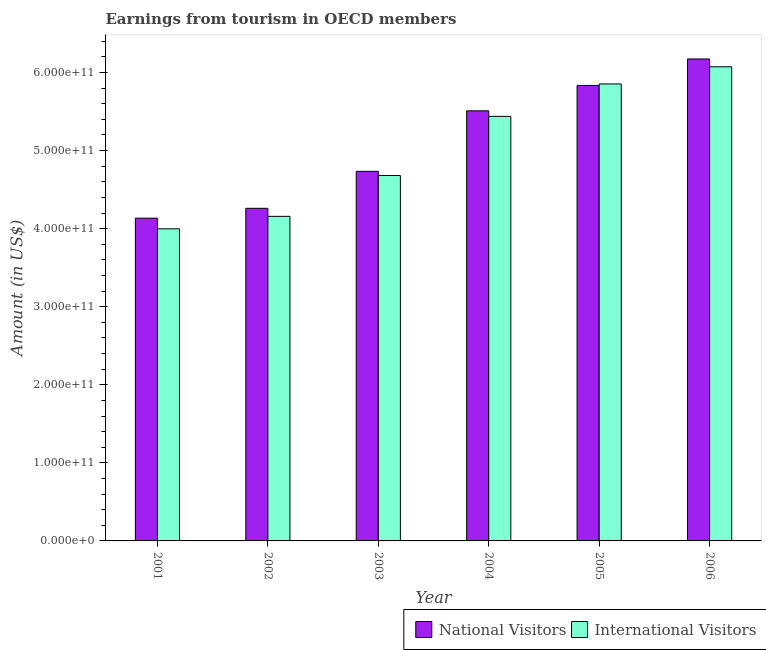How many different coloured bars are there?
Your answer should be very brief. 2. How many groups of bars are there?
Keep it short and to the point. 6. Are the number of bars on each tick of the X-axis equal?
Your response must be concise. Yes. How many bars are there on the 6th tick from the left?
Give a very brief answer. 2. How many bars are there on the 2nd tick from the right?
Ensure brevity in your answer.  2. What is the label of the 2nd group of bars from the left?
Provide a succinct answer. 2002. What is the amount earned from national visitors in 2004?
Offer a very short reply. 5.51e+11. Across all years, what is the maximum amount earned from national visitors?
Your answer should be very brief. 6.17e+11. Across all years, what is the minimum amount earned from national visitors?
Offer a terse response. 4.13e+11. What is the total amount earned from international visitors in the graph?
Offer a terse response. 3.02e+12. What is the difference between the amount earned from international visitors in 2002 and that in 2005?
Your answer should be compact. -1.70e+11. What is the difference between the amount earned from international visitors in 2001 and the amount earned from national visitors in 2004?
Make the answer very short. -1.44e+11. What is the average amount earned from international visitors per year?
Your answer should be very brief. 5.03e+11. In the year 2003, what is the difference between the amount earned from international visitors and amount earned from national visitors?
Ensure brevity in your answer.  0. What is the ratio of the amount earned from national visitors in 2003 to that in 2004?
Your answer should be compact. 0.86. Is the difference between the amount earned from international visitors in 2004 and 2006 greater than the difference between the amount earned from national visitors in 2004 and 2006?
Ensure brevity in your answer.  No. What is the difference between the highest and the second highest amount earned from international visitors?
Give a very brief answer. 2.20e+1. What is the difference between the highest and the lowest amount earned from international visitors?
Offer a terse response. 2.08e+11. In how many years, is the amount earned from international visitors greater than the average amount earned from international visitors taken over all years?
Your answer should be compact. 3. What does the 2nd bar from the left in 2006 represents?
Your answer should be compact. International Visitors. What does the 1st bar from the right in 2001 represents?
Your response must be concise. International Visitors. Are all the bars in the graph horizontal?
Provide a short and direct response. No. How many years are there in the graph?
Your response must be concise. 6. What is the difference between two consecutive major ticks on the Y-axis?
Your answer should be very brief. 1.00e+11. Are the values on the major ticks of Y-axis written in scientific E-notation?
Keep it short and to the point. Yes. Does the graph contain any zero values?
Offer a terse response. No. Where does the legend appear in the graph?
Your answer should be compact. Bottom right. How are the legend labels stacked?
Provide a succinct answer. Horizontal. What is the title of the graph?
Make the answer very short. Earnings from tourism in OECD members. What is the label or title of the Y-axis?
Provide a succinct answer. Amount (in US$). What is the Amount (in US$) of National Visitors in 2001?
Provide a short and direct response. 4.13e+11. What is the Amount (in US$) in International Visitors in 2001?
Provide a succinct answer. 4.00e+11. What is the Amount (in US$) of National Visitors in 2002?
Your response must be concise. 4.26e+11. What is the Amount (in US$) of International Visitors in 2002?
Provide a succinct answer. 4.16e+11. What is the Amount (in US$) in National Visitors in 2003?
Your answer should be very brief. 4.73e+11. What is the Amount (in US$) in International Visitors in 2003?
Your answer should be compact. 4.68e+11. What is the Amount (in US$) in National Visitors in 2004?
Your answer should be compact. 5.51e+11. What is the Amount (in US$) in International Visitors in 2004?
Your answer should be compact. 5.44e+11. What is the Amount (in US$) of National Visitors in 2005?
Your response must be concise. 5.83e+11. What is the Amount (in US$) of International Visitors in 2005?
Your response must be concise. 5.85e+11. What is the Amount (in US$) of National Visitors in 2006?
Give a very brief answer. 6.17e+11. What is the Amount (in US$) of International Visitors in 2006?
Your answer should be very brief. 6.07e+11. Across all years, what is the maximum Amount (in US$) in National Visitors?
Your answer should be compact. 6.17e+11. Across all years, what is the maximum Amount (in US$) in International Visitors?
Offer a terse response. 6.07e+11. Across all years, what is the minimum Amount (in US$) of National Visitors?
Make the answer very short. 4.13e+11. Across all years, what is the minimum Amount (in US$) of International Visitors?
Make the answer very short. 4.00e+11. What is the total Amount (in US$) in National Visitors in the graph?
Give a very brief answer. 3.06e+12. What is the total Amount (in US$) of International Visitors in the graph?
Your response must be concise. 3.02e+12. What is the difference between the Amount (in US$) in National Visitors in 2001 and that in 2002?
Offer a terse response. -1.26e+1. What is the difference between the Amount (in US$) of International Visitors in 2001 and that in 2002?
Your response must be concise. -1.60e+1. What is the difference between the Amount (in US$) in National Visitors in 2001 and that in 2003?
Your answer should be compact. -6.00e+1. What is the difference between the Amount (in US$) of International Visitors in 2001 and that in 2003?
Keep it short and to the point. -6.83e+1. What is the difference between the Amount (in US$) of National Visitors in 2001 and that in 2004?
Your answer should be very brief. -1.37e+11. What is the difference between the Amount (in US$) in International Visitors in 2001 and that in 2004?
Offer a very short reply. -1.44e+11. What is the difference between the Amount (in US$) in National Visitors in 2001 and that in 2005?
Offer a terse response. -1.70e+11. What is the difference between the Amount (in US$) in International Visitors in 2001 and that in 2005?
Offer a terse response. -1.86e+11. What is the difference between the Amount (in US$) in National Visitors in 2001 and that in 2006?
Provide a succinct answer. -2.04e+11. What is the difference between the Amount (in US$) in International Visitors in 2001 and that in 2006?
Keep it short and to the point. -2.08e+11. What is the difference between the Amount (in US$) in National Visitors in 2002 and that in 2003?
Your answer should be very brief. -4.74e+1. What is the difference between the Amount (in US$) in International Visitors in 2002 and that in 2003?
Provide a short and direct response. -5.23e+1. What is the difference between the Amount (in US$) of National Visitors in 2002 and that in 2004?
Provide a short and direct response. -1.25e+11. What is the difference between the Amount (in US$) in International Visitors in 2002 and that in 2004?
Give a very brief answer. -1.28e+11. What is the difference between the Amount (in US$) in National Visitors in 2002 and that in 2005?
Your answer should be very brief. -1.57e+11. What is the difference between the Amount (in US$) in International Visitors in 2002 and that in 2005?
Ensure brevity in your answer.  -1.70e+11. What is the difference between the Amount (in US$) in National Visitors in 2002 and that in 2006?
Offer a very short reply. -1.91e+11. What is the difference between the Amount (in US$) of International Visitors in 2002 and that in 2006?
Keep it short and to the point. -1.92e+11. What is the difference between the Amount (in US$) of National Visitors in 2003 and that in 2004?
Provide a short and direct response. -7.75e+1. What is the difference between the Amount (in US$) in International Visitors in 2003 and that in 2004?
Your answer should be very brief. -7.58e+1. What is the difference between the Amount (in US$) in National Visitors in 2003 and that in 2005?
Offer a very short reply. -1.10e+11. What is the difference between the Amount (in US$) of International Visitors in 2003 and that in 2005?
Offer a terse response. -1.17e+11. What is the difference between the Amount (in US$) of National Visitors in 2003 and that in 2006?
Provide a short and direct response. -1.44e+11. What is the difference between the Amount (in US$) in International Visitors in 2003 and that in 2006?
Ensure brevity in your answer.  -1.39e+11. What is the difference between the Amount (in US$) of National Visitors in 2004 and that in 2005?
Your answer should be compact. -3.26e+1. What is the difference between the Amount (in US$) of International Visitors in 2004 and that in 2005?
Your answer should be compact. -4.15e+1. What is the difference between the Amount (in US$) of National Visitors in 2004 and that in 2006?
Your answer should be compact. -6.64e+1. What is the difference between the Amount (in US$) in International Visitors in 2004 and that in 2006?
Offer a terse response. -6.35e+1. What is the difference between the Amount (in US$) of National Visitors in 2005 and that in 2006?
Offer a terse response. -3.39e+1. What is the difference between the Amount (in US$) in International Visitors in 2005 and that in 2006?
Your answer should be very brief. -2.20e+1. What is the difference between the Amount (in US$) in National Visitors in 2001 and the Amount (in US$) in International Visitors in 2002?
Offer a very short reply. -2.34e+09. What is the difference between the Amount (in US$) of National Visitors in 2001 and the Amount (in US$) of International Visitors in 2003?
Give a very brief answer. -5.47e+1. What is the difference between the Amount (in US$) of National Visitors in 2001 and the Amount (in US$) of International Visitors in 2004?
Offer a terse response. -1.30e+11. What is the difference between the Amount (in US$) of National Visitors in 2001 and the Amount (in US$) of International Visitors in 2005?
Provide a succinct answer. -1.72e+11. What is the difference between the Amount (in US$) of National Visitors in 2001 and the Amount (in US$) of International Visitors in 2006?
Your answer should be very brief. -1.94e+11. What is the difference between the Amount (in US$) of National Visitors in 2002 and the Amount (in US$) of International Visitors in 2003?
Offer a terse response. -4.20e+1. What is the difference between the Amount (in US$) in National Visitors in 2002 and the Amount (in US$) in International Visitors in 2004?
Give a very brief answer. -1.18e+11. What is the difference between the Amount (in US$) in National Visitors in 2002 and the Amount (in US$) in International Visitors in 2005?
Provide a succinct answer. -1.59e+11. What is the difference between the Amount (in US$) of National Visitors in 2002 and the Amount (in US$) of International Visitors in 2006?
Provide a short and direct response. -1.81e+11. What is the difference between the Amount (in US$) of National Visitors in 2003 and the Amount (in US$) of International Visitors in 2004?
Offer a very short reply. -7.04e+1. What is the difference between the Amount (in US$) of National Visitors in 2003 and the Amount (in US$) of International Visitors in 2005?
Offer a very short reply. -1.12e+11. What is the difference between the Amount (in US$) in National Visitors in 2003 and the Amount (in US$) in International Visitors in 2006?
Give a very brief answer. -1.34e+11. What is the difference between the Amount (in US$) in National Visitors in 2004 and the Amount (in US$) in International Visitors in 2005?
Provide a succinct answer. -3.44e+1. What is the difference between the Amount (in US$) of National Visitors in 2004 and the Amount (in US$) of International Visitors in 2006?
Offer a terse response. -5.65e+1. What is the difference between the Amount (in US$) of National Visitors in 2005 and the Amount (in US$) of International Visitors in 2006?
Offer a very short reply. -2.39e+1. What is the average Amount (in US$) of National Visitors per year?
Give a very brief answer. 5.11e+11. What is the average Amount (in US$) of International Visitors per year?
Offer a terse response. 5.03e+11. In the year 2001, what is the difference between the Amount (in US$) in National Visitors and Amount (in US$) in International Visitors?
Offer a very short reply. 1.36e+1. In the year 2002, what is the difference between the Amount (in US$) in National Visitors and Amount (in US$) in International Visitors?
Provide a short and direct response. 1.03e+1. In the year 2003, what is the difference between the Amount (in US$) in National Visitors and Amount (in US$) in International Visitors?
Your response must be concise. 5.36e+09. In the year 2004, what is the difference between the Amount (in US$) in National Visitors and Amount (in US$) in International Visitors?
Ensure brevity in your answer.  7.08e+09. In the year 2005, what is the difference between the Amount (in US$) of National Visitors and Amount (in US$) of International Visitors?
Keep it short and to the point. -1.88e+09. In the year 2006, what is the difference between the Amount (in US$) in National Visitors and Amount (in US$) in International Visitors?
Give a very brief answer. 9.98e+09. What is the ratio of the Amount (in US$) in National Visitors in 2001 to that in 2002?
Your answer should be very brief. 0.97. What is the ratio of the Amount (in US$) of International Visitors in 2001 to that in 2002?
Your answer should be very brief. 0.96. What is the ratio of the Amount (in US$) in National Visitors in 2001 to that in 2003?
Make the answer very short. 0.87. What is the ratio of the Amount (in US$) in International Visitors in 2001 to that in 2003?
Your answer should be compact. 0.85. What is the ratio of the Amount (in US$) of National Visitors in 2001 to that in 2004?
Your answer should be compact. 0.75. What is the ratio of the Amount (in US$) of International Visitors in 2001 to that in 2004?
Provide a succinct answer. 0.74. What is the ratio of the Amount (in US$) in National Visitors in 2001 to that in 2005?
Ensure brevity in your answer.  0.71. What is the ratio of the Amount (in US$) in International Visitors in 2001 to that in 2005?
Give a very brief answer. 0.68. What is the ratio of the Amount (in US$) of National Visitors in 2001 to that in 2006?
Keep it short and to the point. 0.67. What is the ratio of the Amount (in US$) in International Visitors in 2001 to that in 2006?
Offer a very short reply. 0.66. What is the ratio of the Amount (in US$) in National Visitors in 2002 to that in 2003?
Offer a very short reply. 0.9. What is the ratio of the Amount (in US$) of International Visitors in 2002 to that in 2003?
Offer a terse response. 0.89. What is the ratio of the Amount (in US$) in National Visitors in 2002 to that in 2004?
Ensure brevity in your answer.  0.77. What is the ratio of the Amount (in US$) of International Visitors in 2002 to that in 2004?
Your answer should be compact. 0.76. What is the ratio of the Amount (in US$) in National Visitors in 2002 to that in 2005?
Give a very brief answer. 0.73. What is the ratio of the Amount (in US$) in International Visitors in 2002 to that in 2005?
Your answer should be very brief. 0.71. What is the ratio of the Amount (in US$) of National Visitors in 2002 to that in 2006?
Give a very brief answer. 0.69. What is the ratio of the Amount (in US$) of International Visitors in 2002 to that in 2006?
Your response must be concise. 0.68. What is the ratio of the Amount (in US$) in National Visitors in 2003 to that in 2004?
Offer a very short reply. 0.86. What is the ratio of the Amount (in US$) in International Visitors in 2003 to that in 2004?
Keep it short and to the point. 0.86. What is the ratio of the Amount (in US$) in National Visitors in 2003 to that in 2005?
Your answer should be very brief. 0.81. What is the ratio of the Amount (in US$) of International Visitors in 2003 to that in 2005?
Give a very brief answer. 0.8. What is the ratio of the Amount (in US$) of National Visitors in 2003 to that in 2006?
Make the answer very short. 0.77. What is the ratio of the Amount (in US$) of International Visitors in 2003 to that in 2006?
Your answer should be very brief. 0.77. What is the ratio of the Amount (in US$) of National Visitors in 2004 to that in 2005?
Ensure brevity in your answer.  0.94. What is the ratio of the Amount (in US$) of International Visitors in 2004 to that in 2005?
Provide a short and direct response. 0.93. What is the ratio of the Amount (in US$) of National Visitors in 2004 to that in 2006?
Ensure brevity in your answer.  0.89. What is the ratio of the Amount (in US$) in International Visitors in 2004 to that in 2006?
Your answer should be compact. 0.9. What is the ratio of the Amount (in US$) in National Visitors in 2005 to that in 2006?
Provide a short and direct response. 0.95. What is the ratio of the Amount (in US$) in International Visitors in 2005 to that in 2006?
Provide a short and direct response. 0.96. What is the difference between the highest and the second highest Amount (in US$) of National Visitors?
Ensure brevity in your answer.  3.39e+1. What is the difference between the highest and the second highest Amount (in US$) of International Visitors?
Make the answer very short. 2.20e+1. What is the difference between the highest and the lowest Amount (in US$) in National Visitors?
Provide a short and direct response. 2.04e+11. What is the difference between the highest and the lowest Amount (in US$) of International Visitors?
Offer a terse response. 2.08e+11. 